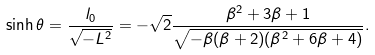<formula> <loc_0><loc_0><loc_500><loc_500>& \sinh \theta = \frac { l _ { 0 } } { \sqrt { - L ^ { 2 } } } = - \sqrt { 2 } \frac { \beta ^ { 2 } + 3 \beta + 1 } { \sqrt { - \beta ( \beta + 2 ) ( \beta ^ { 2 } + 6 \beta + 4 ) } } .</formula> 